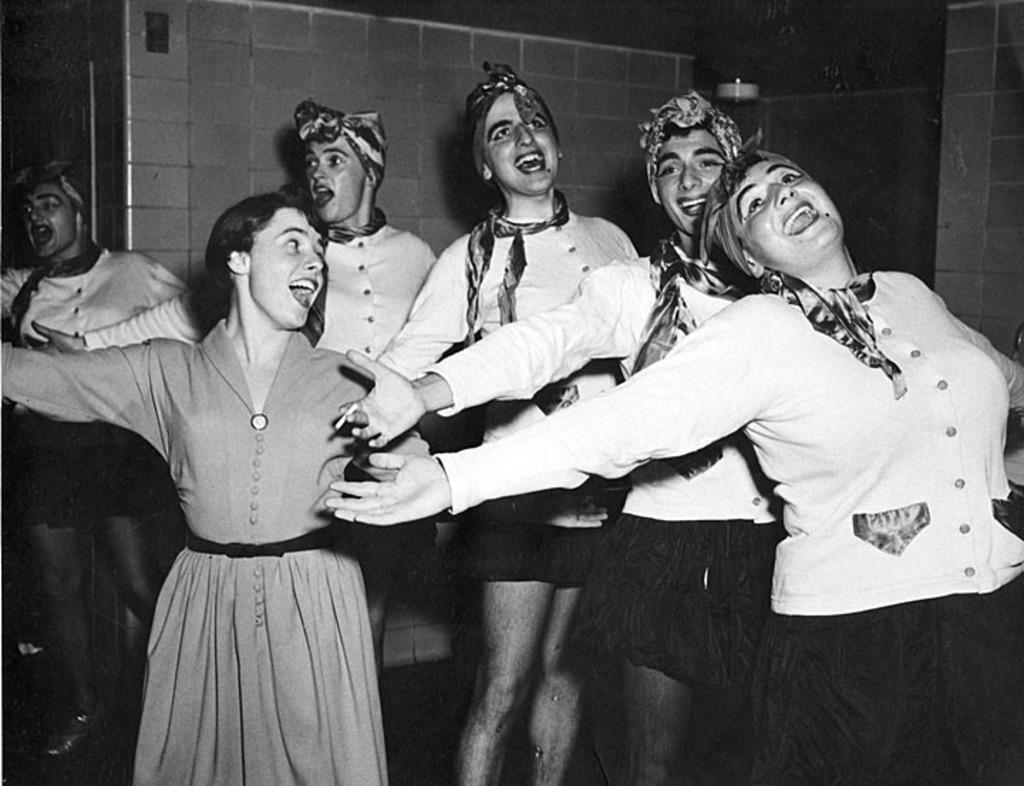How many people are in the image? There is a group of people in the image, but the exact number cannot be determined without more information. What is the background of the image? There is a wall in the image, which serves as the background. What type of glue is being used by the people in the image? There is no glue present in the image, and therefore no such activity can be observed. 